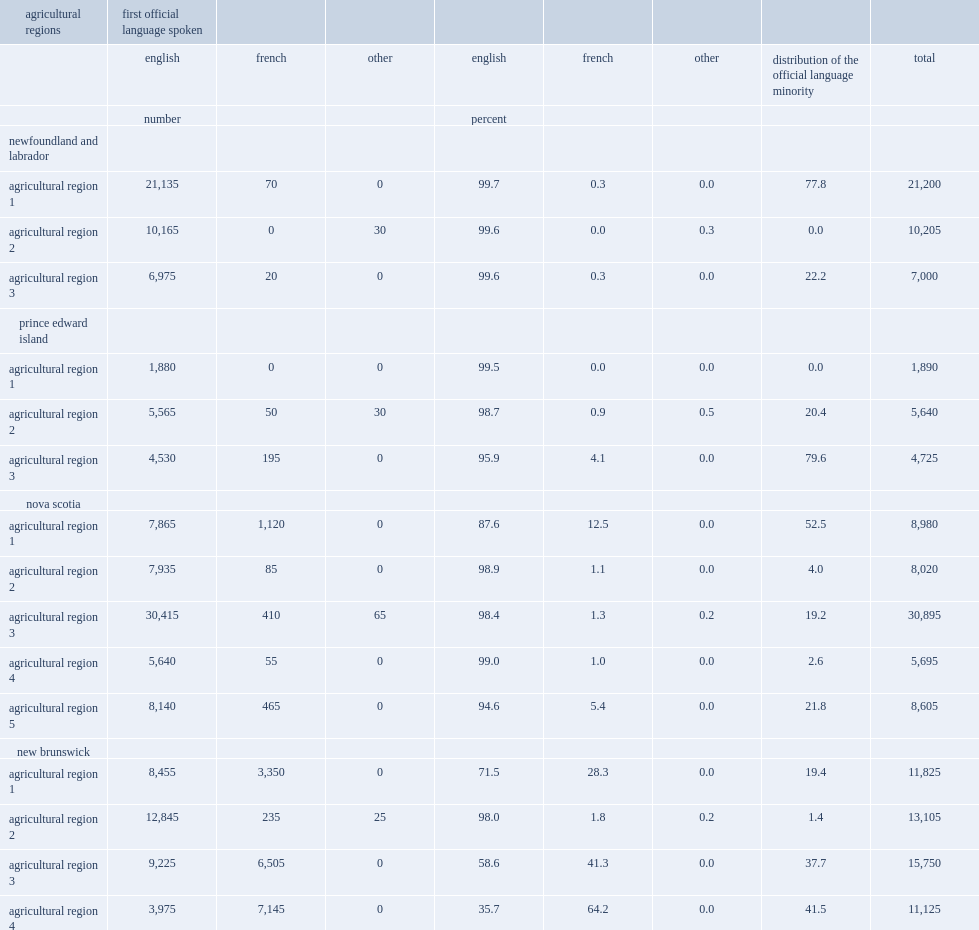How many workers aged 15 and over were in the atlantic canadian agri-food sector? 164660. What regions in the atlantic canadian agri-food sector have more workers aged 15 and over ? New brunswick nova scotia. How many french-language agri-food workers were in the four atlantic provinces? 19705. How many percentage of agri-food workers in new brunswick was french-language workers? 0.33269. How many french-language workers in the agri-food sector were in nova scotia? 2135. How many french-language workers in the agri-food sector were in prince edward island? 245. 